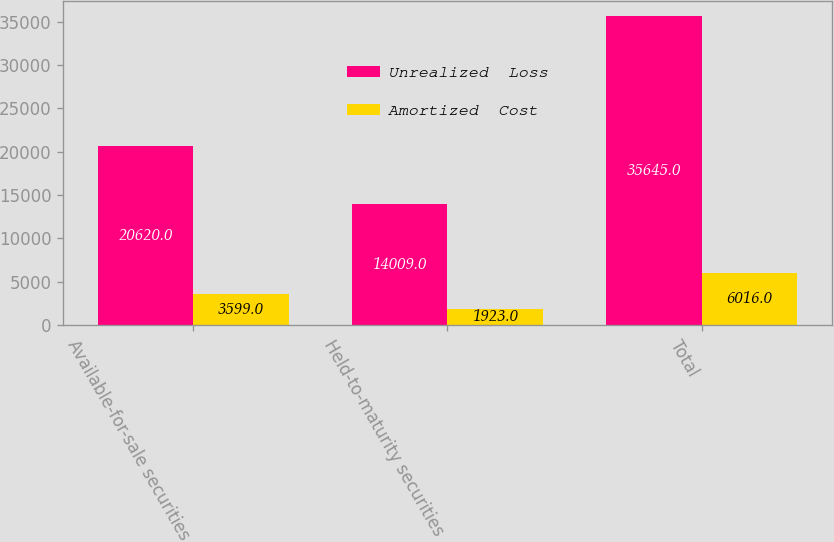Convert chart. <chart><loc_0><loc_0><loc_500><loc_500><stacked_bar_chart><ecel><fcel>Available-for-sale securities<fcel>Held-to-maturity securities<fcel>Total<nl><fcel>Unrealized  Loss<fcel>20620<fcel>14009<fcel>35645<nl><fcel>Amortized  Cost<fcel>3599<fcel>1923<fcel>6016<nl></chart> 